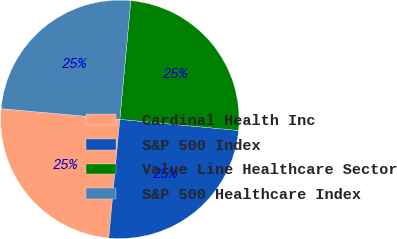Convert chart. <chart><loc_0><loc_0><loc_500><loc_500><pie_chart><fcel>Cardinal Health Inc<fcel>S&P 500 Index<fcel>Value Line Healthcare Sector<fcel>S&P 500 Healthcare Index<nl><fcel>24.96%<fcel>24.99%<fcel>25.01%<fcel>25.04%<nl></chart> 